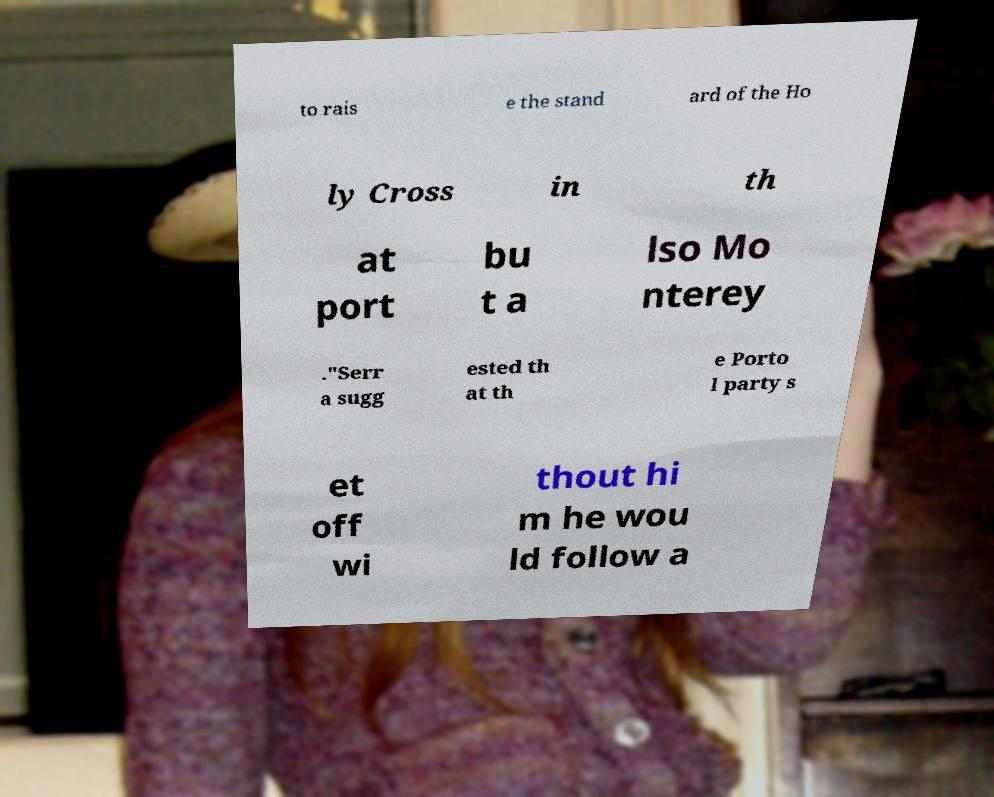There's text embedded in this image that I need extracted. Can you transcribe it verbatim? to rais e the stand ard of the Ho ly Cross in th at port bu t a lso Mo nterey ."Serr a sugg ested th at th e Porto l party s et off wi thout hi m he wou ld follow a 